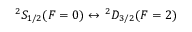<formula> <loc_0><loc_0><loc_500><loc_500>{ } ^ { 2 } S _ { 1 / 2 } ( F = 0 ) \leftrightarrow ^ { 2 } D _ { 3 / 2 } ( F = 2 )</formula> 